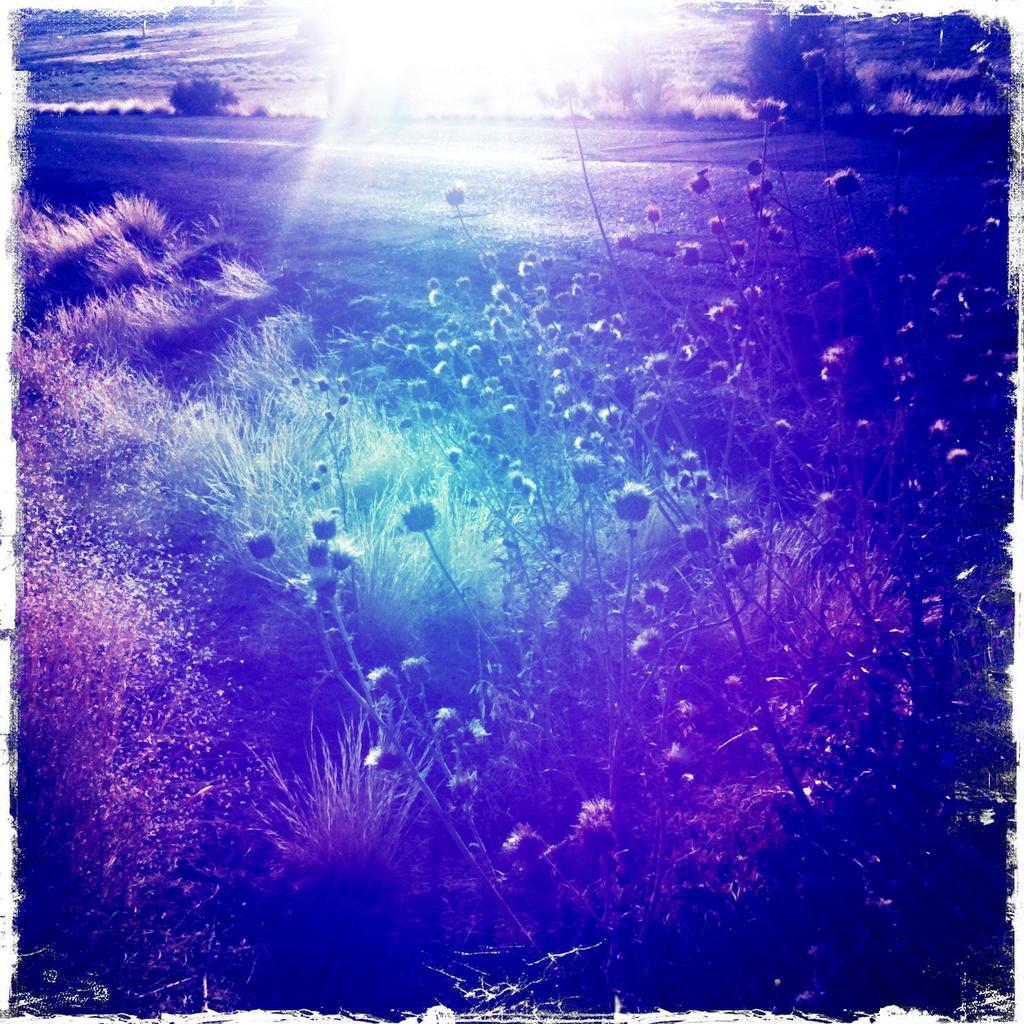Describe this image in one or two sentences. This is an edited image. In this image we can see a group of plants, trees and grass. 